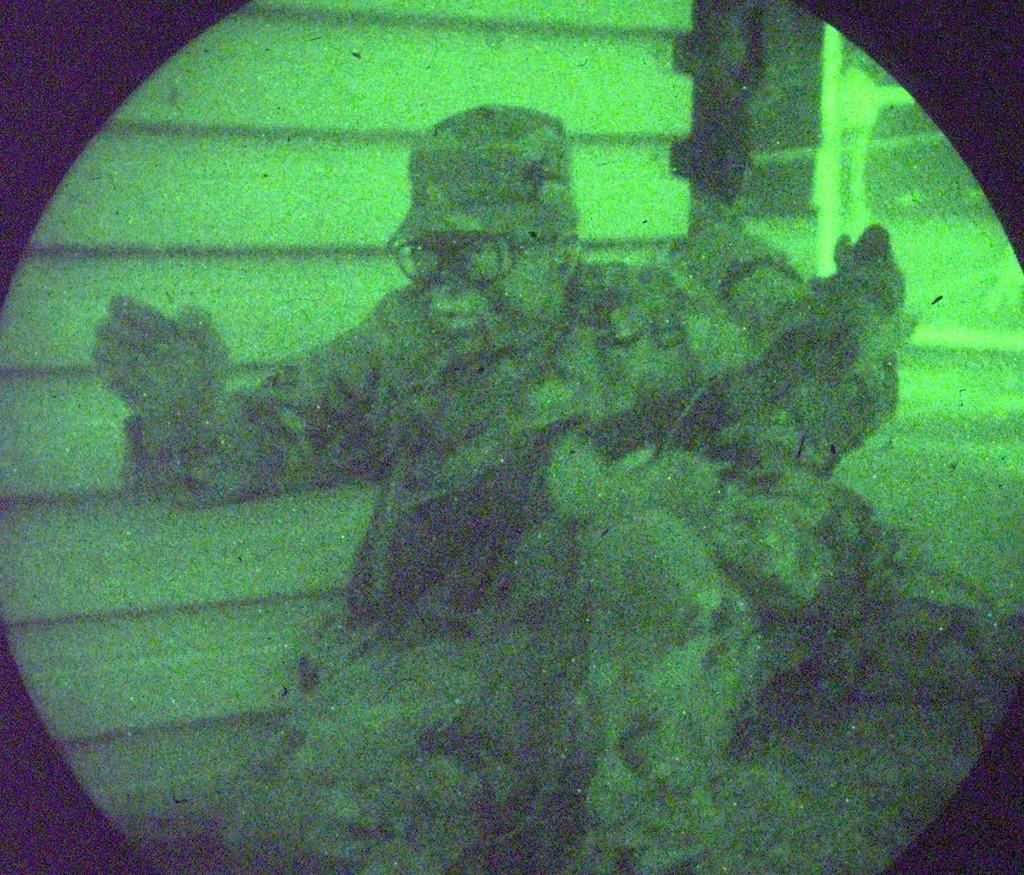Who or what is present in the image? There is a person in the image. What can be seen in the background of the image? There is a wall in the image. What type of tent is visible in the image? There is no tent present in the image. What show is the person attending in the image? There is no indication of a show or event in the image. 